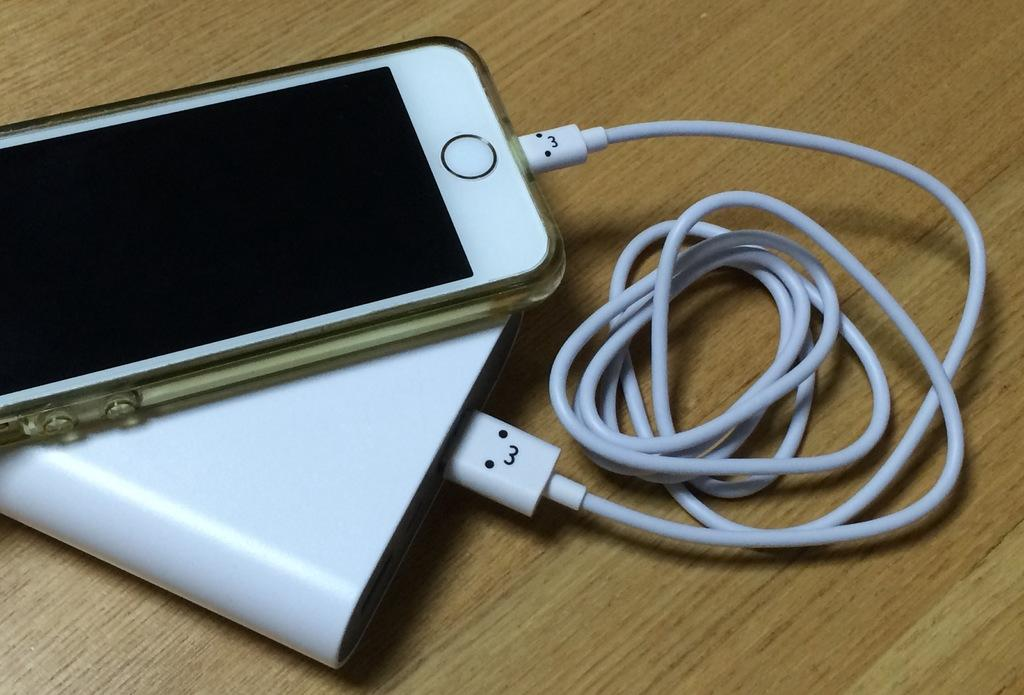What type of device is visible in the image? There is a mobile in the image. What other electronic device can be seen in the image? There is a power bank in the image. Is there any connecting device between the mobile and power bank? Yes, there is a cable in the image. Where are these objects located in the image? All these objects are on a table. What type of watch is visible on the table in the image? There is no watch present in the image. How many divisions can be seen on the tail of the mobile in the image? There is no tail present on the mobile in the image. 